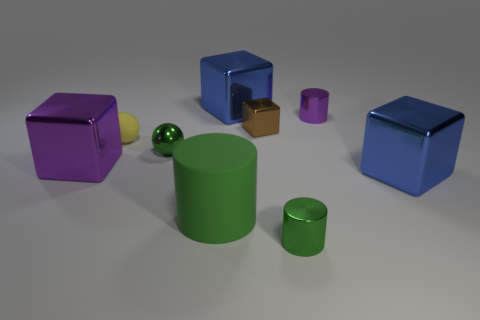Subtract all purple cylinders. How many cylinders are left? 2 Subtract all metal cylinders. How many cylinders are left? 1 Subtract all red spheres. How many purple cylinders are left? 1 Subtract all shiny blocks. Subtract all big green objects. How many objects are left? 4 Add 4 brown metallic blocks. How many brown metallic blocks are left? 5 Add 9 rubber cylinders. How many rubber cylinders exist? 10 Subtract 0 cyan cylinders. How many objects are left? 9 Subtract all blocks. How many objects are left? 5 Subtract all red balls. Subtract all brown cylinders. How many balls are left? 2 